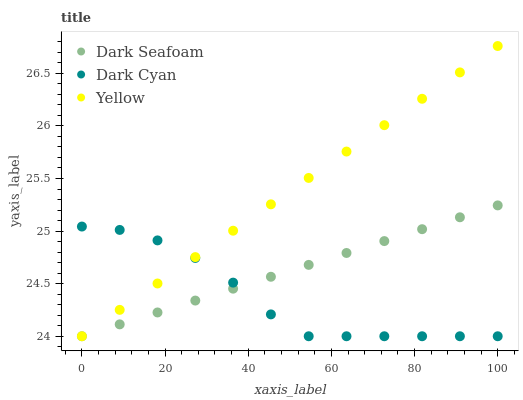Does Dark Cyan have the minimum area under the curve?
Answer yes or no. Yes. Does Yellow have the maximum area under the curve?
Answer yes or no. Yes. Does Dark Seafoam have the minimum area under the curve?
Answer yes or no. No. Does Dark Seafoam have the maximum area under the curve?
Answer yes or no. No. Is Dark Seafoam the smoothest?
Answer yes or no. Yes. Is Dark Cyan the roughest?
Answer yes or no. Yes. Is Yellow the smoothest?
Answer yes or no. No. Is Yellow the roughest?
Answer yes or no. No. Does Dark Cyan have the lowest value?
Answer yes or no. Yes. Does Yellow have the highest value?
Answer yes or no. Yes. Does Dark Seafoam have the highest value?
Answer yes or no. No. Does Yellow intersect Dark Cyan?
Answer yes or no. Yes. Is Yellow less than Dark Cyan?
Answer yes or no. No. Is Yellow greater than Dark Cyan?
Answer yes or no. No. 